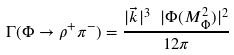<formula> <loc_0><loc_0><loc_500><loc_500>\Gamma ( \Phi \rightarrow \rho ^ { + } \pi ^ { - } ) = \frac { | \vec { k } | ^ { 3 } \ | \Phi ( M _ { \Phi } ^ { 2 } ) | ^ { 2 } } { 1 2 \pi }</formula> 